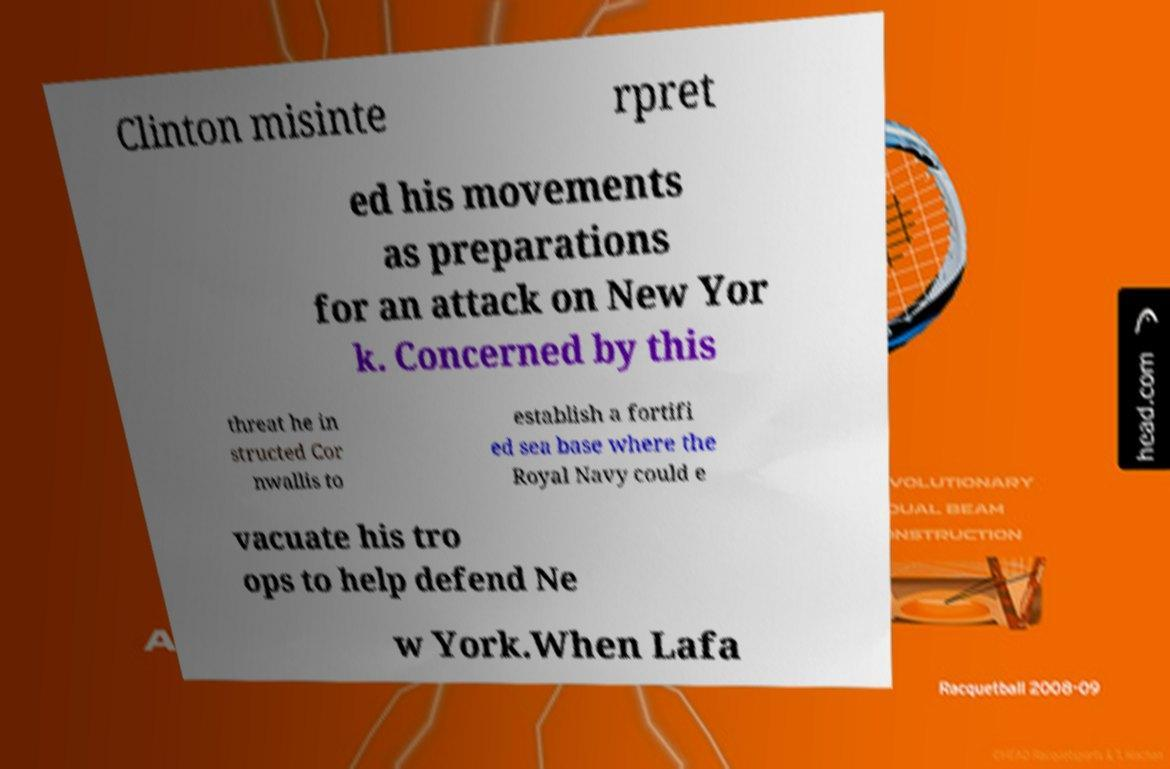Please read and relay the text visible in this image. What does it say? Clinton misinte rpret ed his movements as preparations for an attack on New Yor k. Concerned by this threat he in structed Cor nwallis to establish a fortifi ed sea base where the Royal Navy could e vacuate his tro ops to help defend Ne w York.When Lafa 